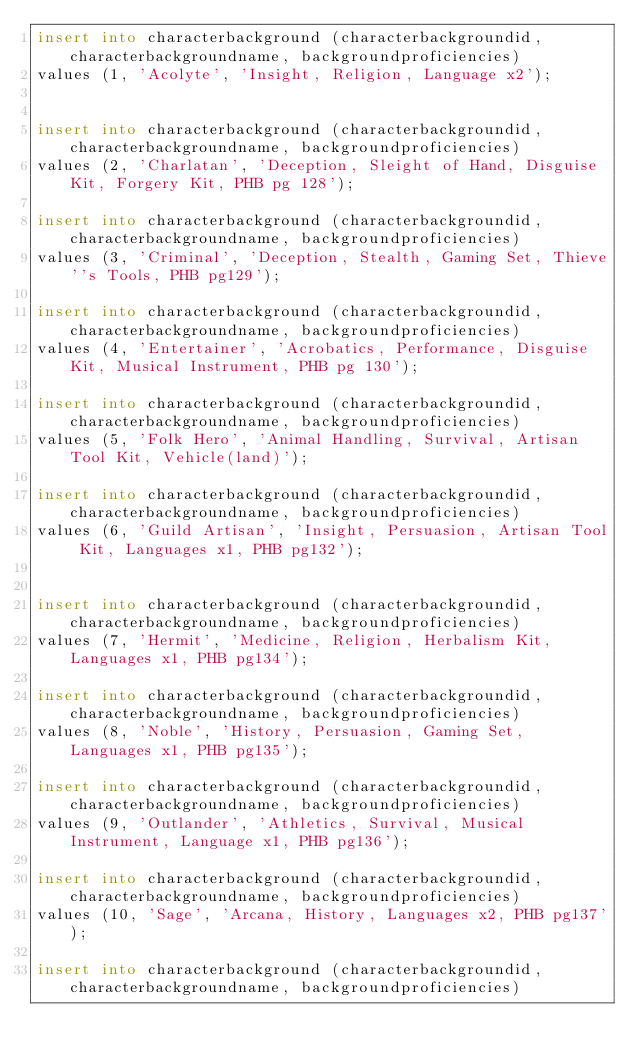Convert code to text. <code><loc_0><loc_0><loc_500><loc_500><_SQL_>insert into characterbackground (characterbackgroundid, characterbackgroundname, backgroundproficiencies)
values (1, 'Acolyte', 'Insight, Religion, Language x2');


insert into characterbackground (characterbackgroundid, characterbackgroundname, backgroundproficiencies)
values (2, 'Charlatan', 'Deception, Sleight of Hand, Disguise Kit, Forgery Kit, PHB pg 128');

insert into characterbackground (characterbackgroundid, characterbackgroundname, backgroundproficiencies)
values (3, 'Criminal', 'Deception, Stealth, Gaming Set, Thieve''s Tools, PHB pg129');

insert into characterbackground (characterbackgroundid, characterbackgroundname, backgroundproficiencies)
values (4, 'Entertainer', 'Acrobatics, Performance, Disguise Kit, Musical Instrument, PHB pg 130');

insert into characterbackground (characterbackgroundid, characterbackgroundname, backgroundproficiencies)
values (5, 'Folk Hero', 'Animal Handling, Survival, Artisan Tool Kit, Vehicle(land)');

insert into characterbackground (characterbackgroundid, characterbackgroundname, backgroundproficiencies)
values (6, 'Guild Artisan', 'Insight, Persuasion, Artisan Tool Kit, Languages x1, PHB pg132');


insert into characterbackground (characterbackgroundid, characterbackgroundname, backgroundproficiencies)
values (7, 'Hermit', 'Medicine, Religion, Herbalism Kit, Languages x1, PHB pg134');

insert into characterbackground (characterbackgroundid, characterbackgroundname, backgroundproficiencies)
values (8, 'Noble', 'History, Persuasion, Gaming Set, Languages x1, PHB pg135');

insert into characterbackground (characterbackgroundid, characterbackgroundname, backgroundproficiencies)
values (9, 'Outlander', 'Athletics, Survival, Musical Instrument, Language x1, PHB pg136');

insert into characterbackground (characterbackgroundid, characterbackgroundname, backgroundproficiencies)
values (10, 'Sage', 'Arcana, History, Languages x2, PHB pg137');

insert into characterbackground (characterbackgroundid, characterbackgroundname, backgroundproficiencies)</code> 